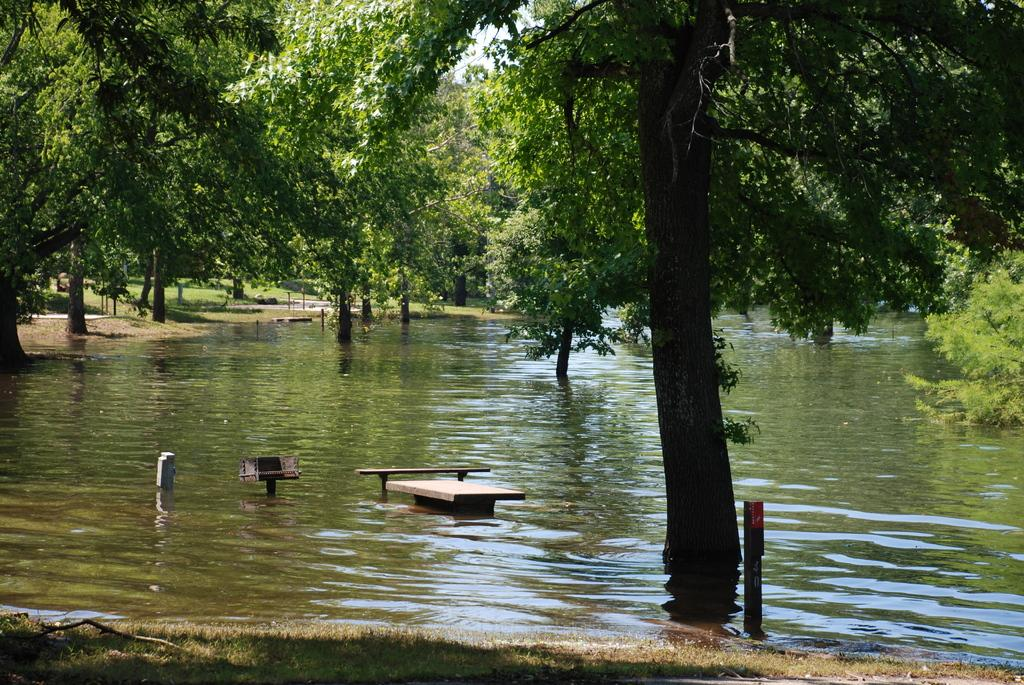What is visible in the image? There is water and green trees visible in the image. Can you describe the water in the image? The facts provided do not give specific details about the water, but it is visible in the image. What type of vegetation is present in the image? Green trees are present in the image. What is the title of the book that is being read by the tomatoes in the image? There are no tomatoes or books present in the image; it only features water and green trees. 